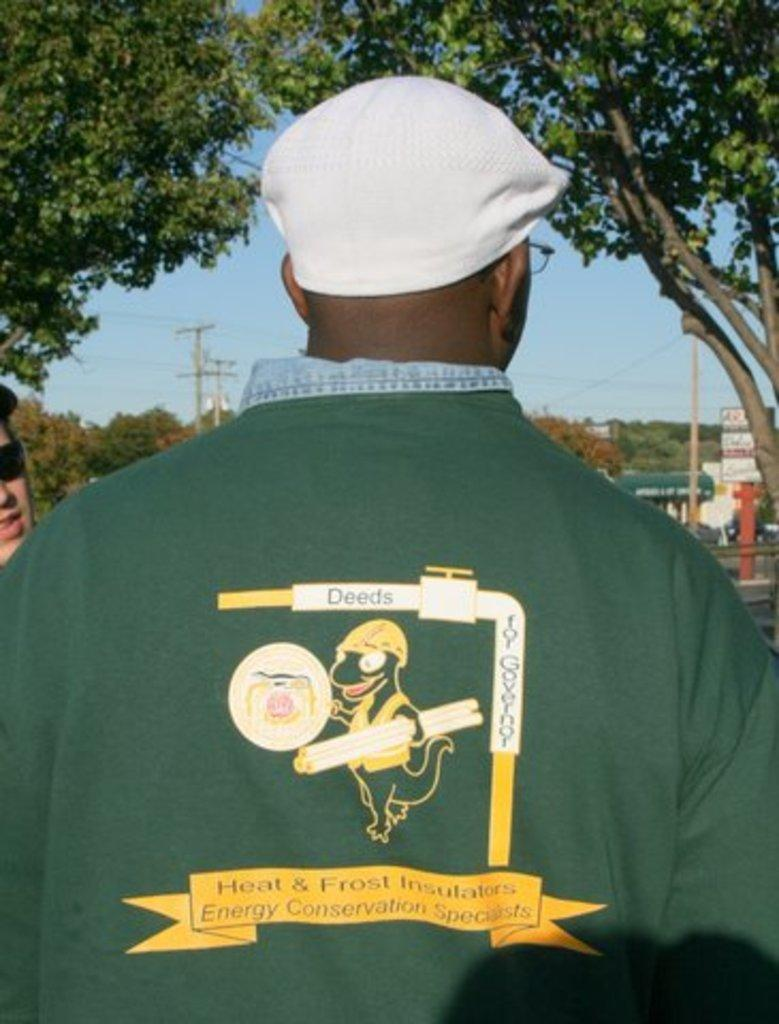What is the main subject of the image? There is a man standing in the image. What is the man wearing on his head? The man is wearing a cap. What type of natural elements can be seen in the image? There are trees in the image. What is visible in the background of the image? The sky is visible in the image. What type of button can be seen on the man's shirt in the image? There is no button visible on the man's shirt in the image. How does the man react to the church in the image? There is no church present in the image, so the man's reaction cannot be determined. 